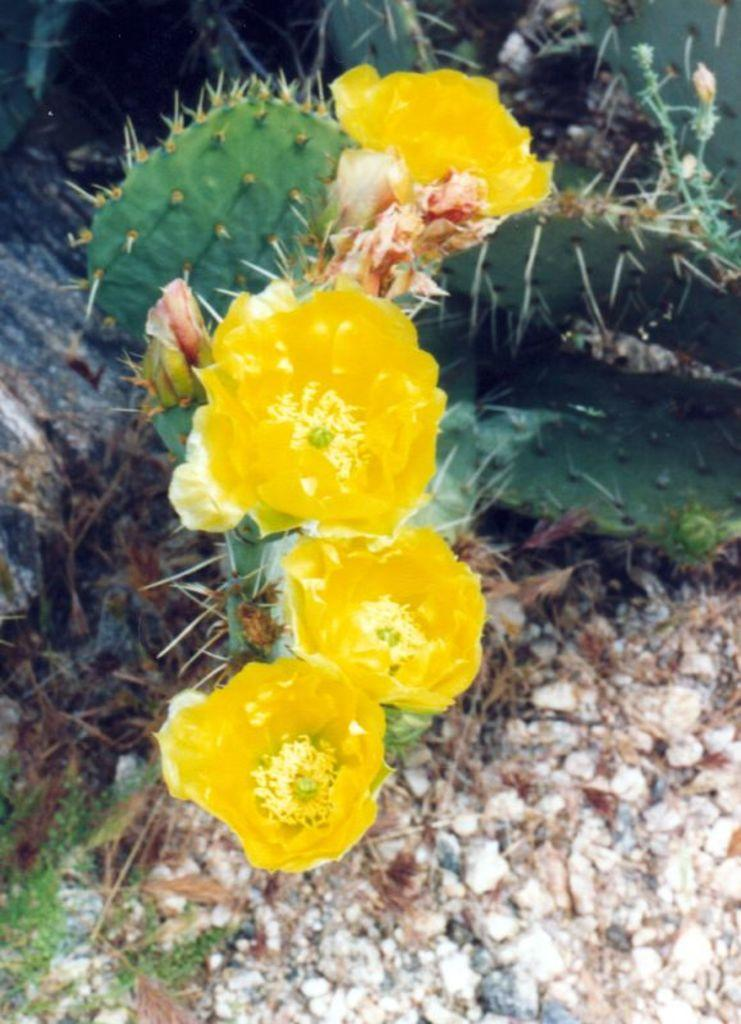What type of plant is in the image? There is a cactus plant in the image. What additional feature can be seen on the cactus plant? The cactus plant has flowers. What color are the flowers on the cactus plant? The flowers are yellow in color. What other objects can be seen in the image? There are stones visible in the image. Who is the governor of the state in the image? There is no reference to a governor or a state in the image; it features a cactus plant with flowers and stones. 